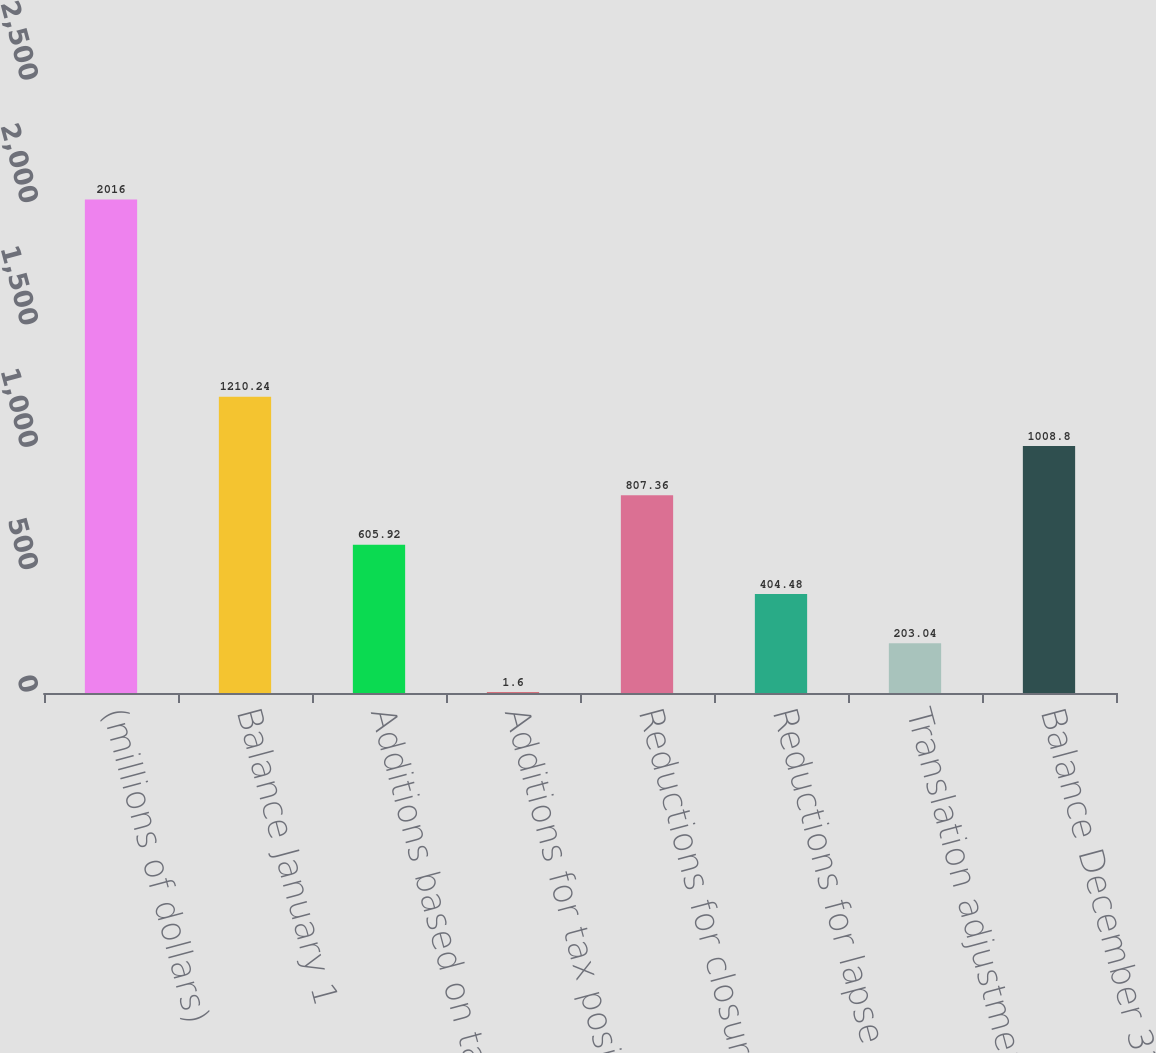<chart> <loc_0><loc_0><loc_500><loc_500><bar_chart><fcel>(millions of dollars)<fcel>Balance January 1<fcel>Additions based on tax<fcel>Additions for tax positions of<fcel>Reductions for closure of tax<fcel>Reductions for lapse in<fcel>Translation adjustment<fcel>Balance December 31<nl><fcel>2016<fcel>1210.24<fcel>605.92<fcel>1.6<fcel>807.36<fcel>404.48<fcel>203.04<fcel>1008.8<nl></chart> 